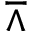<formula> <loc_0><loc_0><loc_500><loc_500>\bar { w } e d g e</formula> 